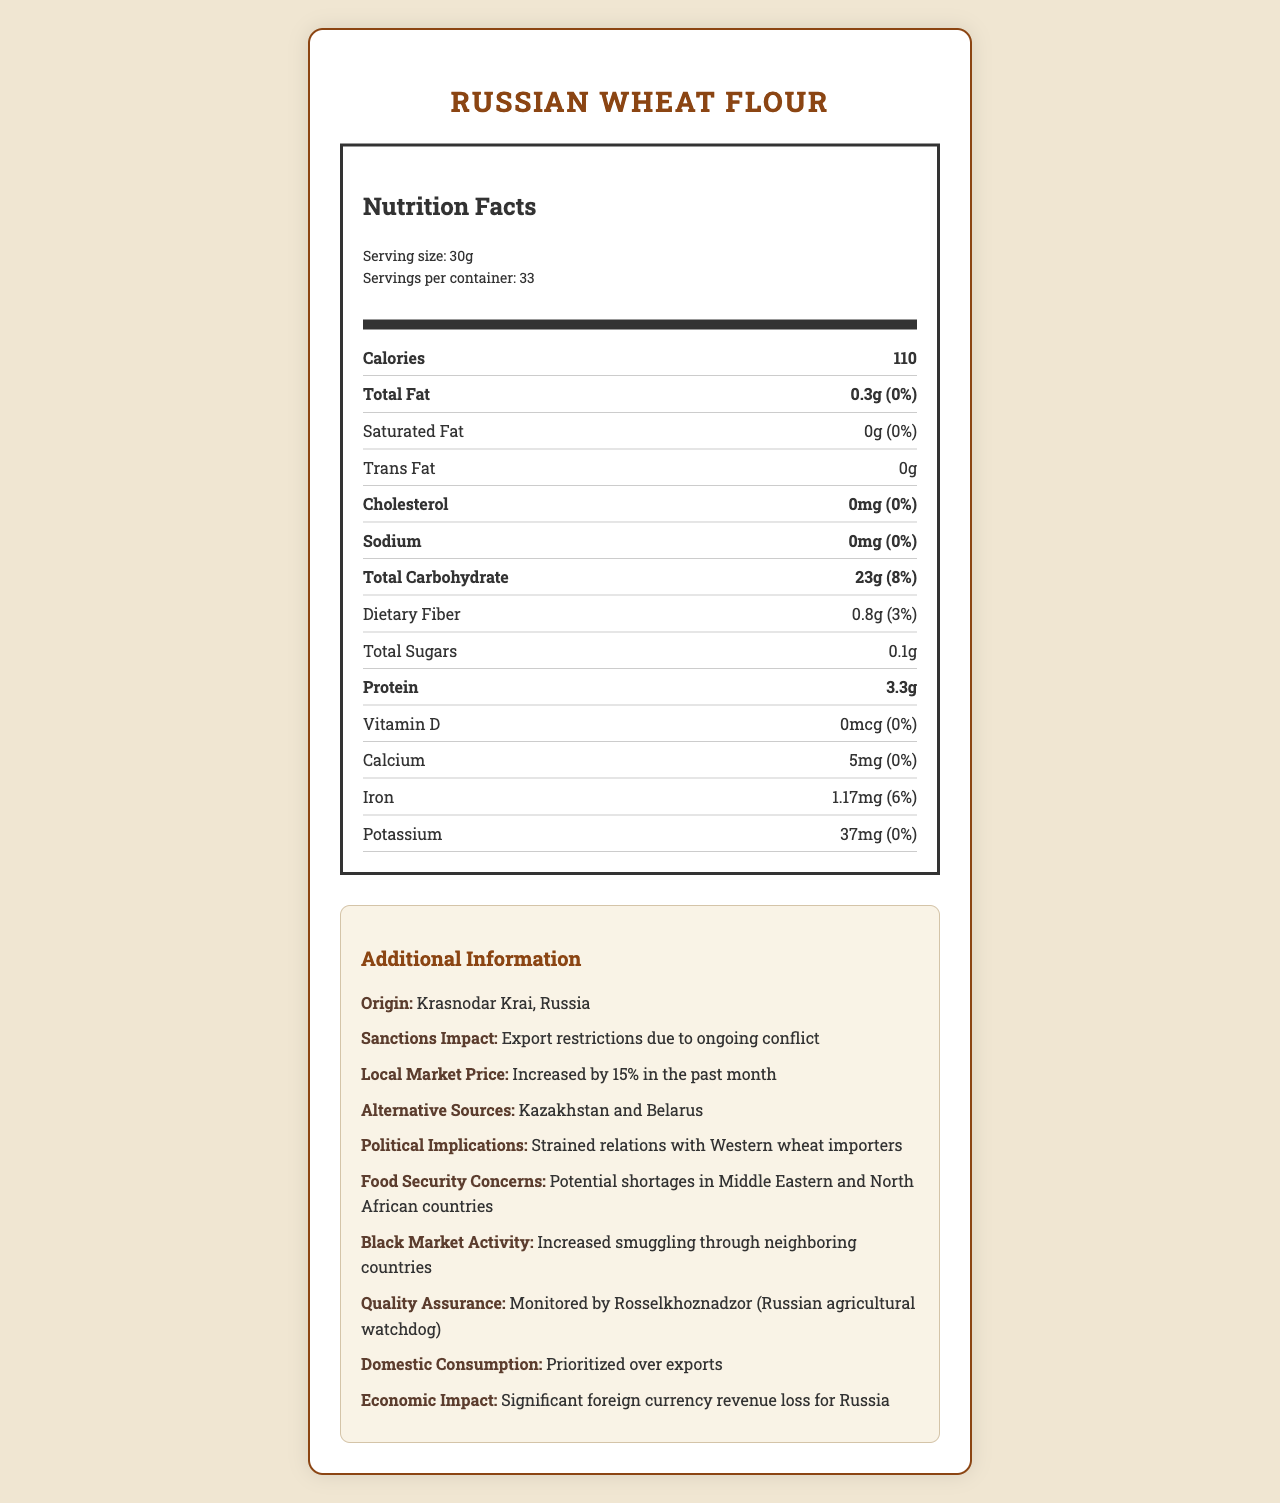What is the serving size of Russian Wheat Flour? The serving size is explicitly mentioned in the "Serving size" section of the document.
Answer: 30g How many calories are in one serving of Russian Wheat Flour? The calories per serving are listed under the "Calories" section.
Answer: 110 What is the percentage daily value of iron in Russian Wheat Flour? The document states that the daily value of iron for one serving is 6%.
Answer: 6% List the countries mentioned as alternative sources for wheat. In the "Additional Information" section under "Alternative Sources," Kazakhstan and Belarus are listed.
Answer: Kazakhstan and Belarus What amount of protein is present in a serving of Russian Wheat Flour? The protein content is mentioned in the "Protein" section.
Answer: 3.3g Which of the following nutrients have a daily value of 0% in Russian Wheat Flour? A. Total Fat B. Sodium C. Iron D. Protein Both Total Fat and Sodium have a daily value of 0%, as indicated in their respective sections in the document.
Answer: A, B What has been the economic impact on Russia due to export restrictions? A. Increased imports B. Increased revenue C. Significant foreign currency revenue loss D. Stabilized market prices The "economic impact" section mentions significant foreign currency revenue loss for Russia.
Answer: C True or False: There is no dietary fiber in Russian Wheat Flour. The nutrient section indicates 0.8g of dietary fiber, which is not zero.
Answer: False Summarize the nutritional and additional information provided about Russian Wheat Flour. The document details the nutritional composition of Russian Wheat Flour, including calories, protein, carbohydrates, and minerals. It also provides extensive context on the geopolitical and economic impacts affecting the product.
Answer: Russian Wheat Flour has a serving size of 30g with 110 calories per serving. It contains minor amounts of fat, dietary fiber, and protein. The product originates from Krasnodar Krai, Russia, and its export has been affected by sanctions and conflicts, causing increased local prices and other economic implications. What has been the impact on local market prices for Russian Wheat Flour recently? The "Local Market Price" information section states that prices have increased by 15%.
Answer: Increased by 15% in the past month What is the origin of the Russian Wheat Flour? The origin is listed under the "Origin" section in Additional Information.
Answer: Krasnodar Krai, Russia Who monitors the quality assurance of Russian Wheat Flour? The "Quality Assurance" section states that the product is monitored by Rosselkhoznadzor.
Answer: Rosselkhoznadzor (Russian agricultural watchdog) What are the potential food security concerns related to Russian Wheat Flour? The "Food Security Concerns" section mentions potential shortages in these regions.
Answer: Potential shortages in Middle Eastern and North African countries Has black market activity increased or decreased for Russian Wheat Flour? The "Black Market Activity" section indicates that smuggling has increased through neighboring countries.
Answer: Increased What is the amount of total carbohydrate per serving of Russian Wheat Flour? The "Total Carbohydrate" section states 23g per serving.
Answer: 23g What’s the impact of the sanctions on the Western wheat importers' relationship with Russia? The "Political Implications" section states that relations have become strained.
Answer: Strained relations with Western wheat importers Which Middle Eastern countries are experiencing food shortages because of the sanctions? The document mentions potential shortages in Middle Eastern and North African countries but doesn't specify which ones.
Answer: Cannot be determined 